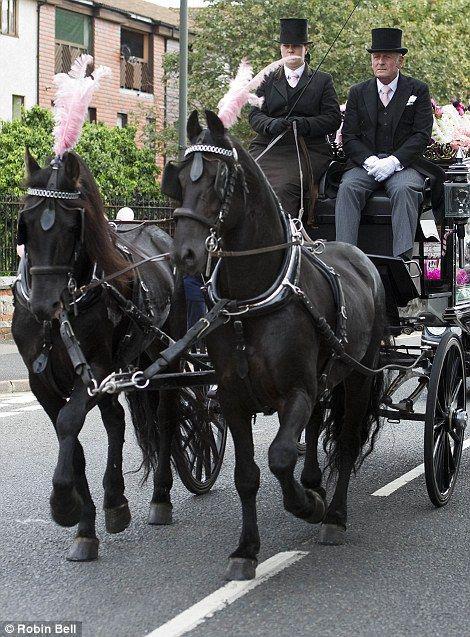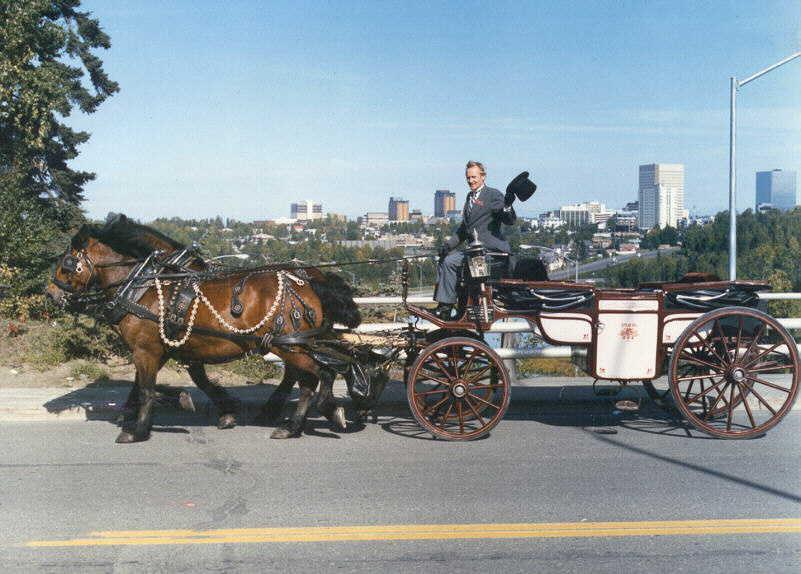The first image is the image on the left, the second image is the image on the right. For the images shown, is this caption "In one image, there are a pair of horses drawing a carriage holding one person to the left." true? Answer yes or no. Yes. The first image is the image on the left, the second image is the image on the right. For the images shown, is this caption "At least one of the horses is white." true? Answer yes or no. No. 